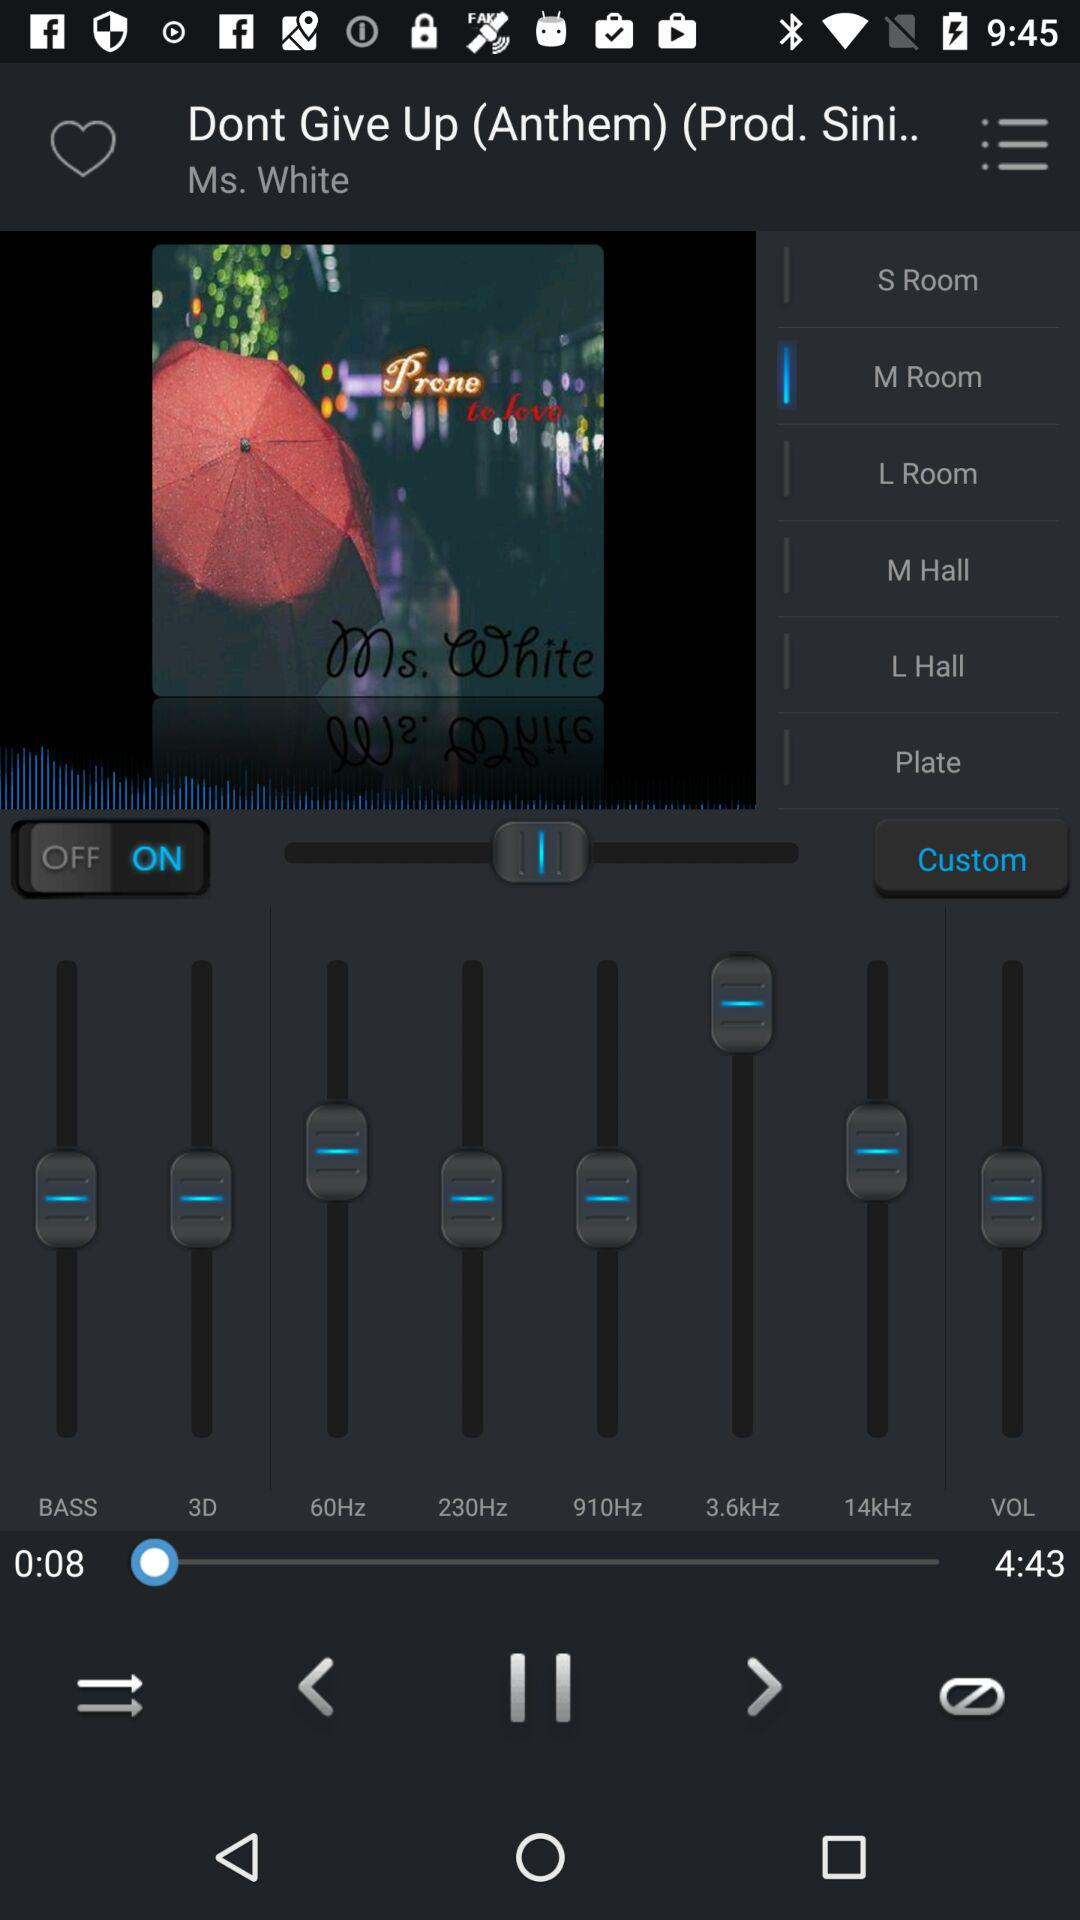What is the duration of the song? The duration of the song is 4:43. 